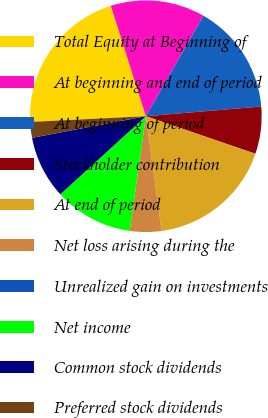<chart> <loc_0><loc_0><loc_500><loc_500><pie_chart><fcel>Total Equity at Beginning of<fcel>At beginning and end of period<fcel>At beginning of period<fcel>Stockholder contribution<fcel>At end of period<fcel>Net loss arising during the<fcel>Unrealized gain on investments<fcel>Net income<fcel>Common stock dividends<fcel>Preferred stock dividends<nl><fcel>20.9%<fcel>13.18%<fcel>15.38%<fcel>6.59%<fcel>17.57%<fcel>4.4%<fcel>0.0%<fcel>10.99%<fcel>8.79%<fcel>2.2%<nl></chart> 